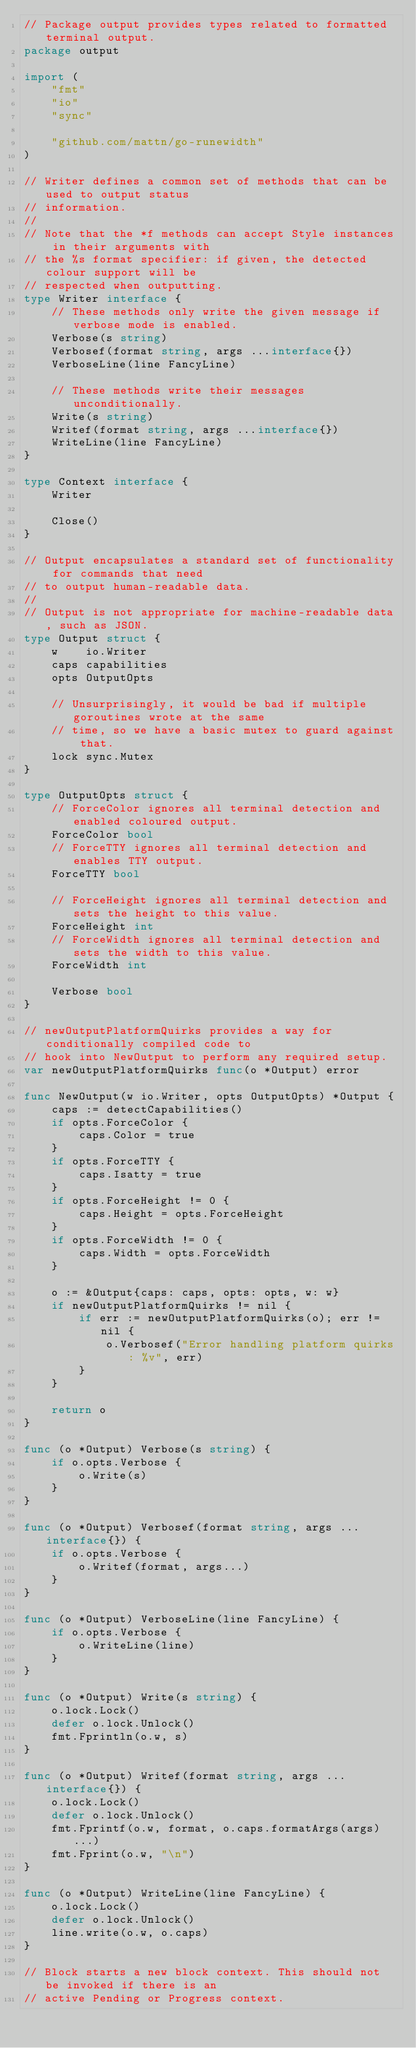Convert code to text. <code><loc_0><loc_0><loc_500><loc_500><_Go_>// Package output provides types related to formatted terminal output.
package output

import (
	"fmt"
	"io"
	"sync"

	"github.com/mattn/go-runewidth"
)

// Writer defines a common set of methods that can be used to output status
// information.
//
// Note that the *f methods can accept Style instances in their arguments with
// the %s format specifier: if given, the detected colour support will be
// respected when outputting.
type Writer interface {
	// These methods only write the given message if verbose mode is enabled.
	Verbose(s string)
	Verbosef(format string, args ...interface{})
	VerboseLine(line FancyLine)

	// These methods write their messages unconditionally.
	Write(s string)
	Writef(format string, args ...interface{})
	WriteLine(line FancyLine)
}

type Context interface {
	Writer

	Close()
}

// Output encapsulates a standard set of functionality for commands that need
// to output human-readable data.
//
// Output is not appropriate for machine-readable data, such as JSON.
type Output struct {
	w    io.Writer
	caps capabilities
	opts OutputOpts

	// Unsurprisingly, it would be bad if multiple goroutines wrote at the same
	// time, so we have a basic mutex to guard against that.
	lock sync.Mutex
}

type OutputOpts struct {
	// ForceColor ignores all terminal detection and enabled coloured output.
	ForceColor bool
	// ForceTTY ignores all terminal detection and enables TTY output.
	ForceTTY bool

	// ForceHeight ignores all terminal detection and sets the height to this value.
	ForceHeight int
	// ForceWidth ignores all terminal detection and sets the width to this value.
	ForceWidth int

	Verbose bool
}

// newOutputPlatformQuirks provides a way for conditionally compiled code to
// hook into NewOutput to perform any required setup.
var newOutputPlatformQuirks func(o *Output) error

func NewOutput(w io.Writer, opts OutputOpts) *Output {
	caps := detectCapabilities()
	if opts.ForceColor {
		caps.Color = true
	}
	if opts.ForceTTY {
		caps.Isatty = true
	}
	if opts.ForceHeight != 0 {
		caps.Height = opts.ForceHeight
	}
	if opts.ForceWidth != 0 {
		caps.Width = opts.ForceWidth
	}

	o := &Output{caps: caps, opts: opts, w: w}
	if newOutputPlatformQuirks != nil {
		if err := newOutputPlatformQuirks(o); err != nil {
			o.Verbosef("Error handling platform quirks: %v", err)
		}
	}

	return o
}

func (o *Output) Verbose(s string) {
	if o.opts.Verbose {
		o.Write(s)
	}
}

func (o *Output) Verbosef(format string, args ...interface{}) {
	if o.opts.Verbose {
		o.Writef(format, args...)
	}
}

func (o *Output) VerboseLine(line FancyLine) {
	if o.opts.Verbose {
		o.WriteLine(line)
	}
}

func (o *Output) Write(s string) {
	o.lock.Lock()
	defer o.lock.Unlock()
	fmt.Fprintln(o.w, s)
}

func (o *Output) Writef(format string, args ...interface{}) {
	o.lock.Lock()
	defer o.lock.Unlock()
	fmt.Fprintf(o.w, format, o.caps.formatArgs(args)...)
	fmt.Fprint(o.w, "\n")
}

func (o *Output) WriteLine(line FancyLine) {
	o.lock.Lock()
	defer o.lock.Unlock()
	line.write(o.w, o.caps)
}

// Block starts a new block context. This should not be invoked if there is an
// active Pending or Progress context.</code> 